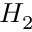<formula> <loc_0><loc_0><loc_500><loc_500>H _ { 2 }</formula> 